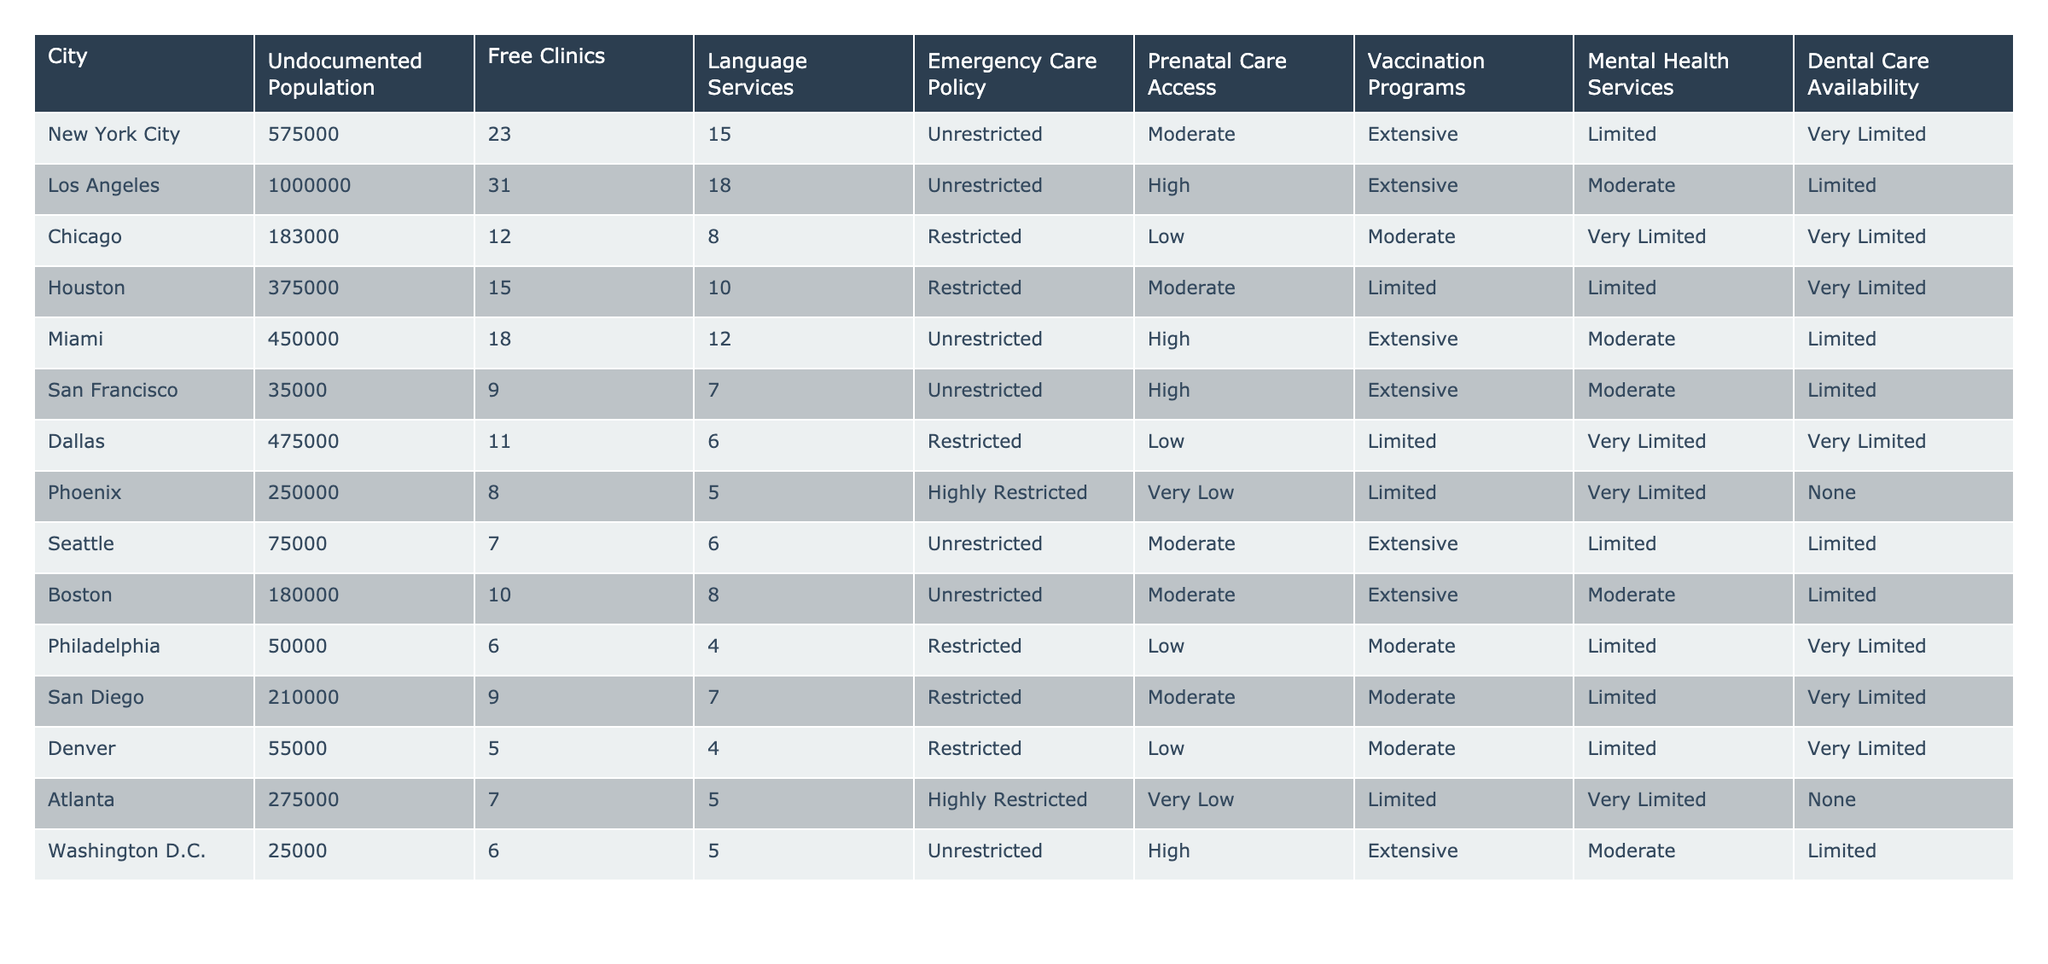What city has the highest undocumented population? By examining the "Undocumented Population" column in the table, Los Angeles has the highest number with 1,000,000.
Answer: Los Angeles Which city has the least access to dental care services for undocumented immigrants? By looking at the "Dental Care Availability" column, both Dallas and Atlanta are marked as "Very Limited," indicating the least access.
Answer: Dallas and Atlanta How many cities have unrestricted emergency care policies? The "Emergency Care Policy" column shows that New York City, Los Angeles, Miami, Seattle, Boston, and Washington D.C. have "Unrestricted" policies, totaling 6 cities.
Answer: 6 What is the average number of free clinics across the cities listed? To find the average, sum the number of free clinics (23 + 31 + 12 + 15 + 18 + 9 + 11 + 8 + 7 + 10 + 6 + 9 + 5 + 7) =  146; divide by the total number of cities, which is 14, giving an average of 146 / 14 ≈ 10.43.
Answer: Approximately 10.43 Which city has the highest number of vaccination programs available? The "Vaccination Programs" column reveals that both New York City, Miami, and San Francisco have "Extensive," but Miami is the only one directly listed with "High," indicating it has the maximum.
Answer: Miami Is prenatal care access restricted in Chicago? The "Prenatal Care Access" column shows "Restricted" for Chicago, confirming that access is indeed restricted.
Answer: Yes Which city has a high availability of mental health services but limited dental care availability? According to the "Mental Health Services" and "Dental Care Availability" columns, Miami has "Extensive" mental health services but "Limited" dental care availability.
Answer: Miami How does the total number of free clinics compare between New York City and Houston? New York City has 23 free clinics while Houston has 15, representing a difference of 8 more clinics in New York City than in Houston.
Answer: New York City has 8 more free clinics Which city has the most access to prenatal care and how is it categorized? Miami has the highest access to prenatal care categorized as "High."
Answer: Miami, High What percentage of cities listed have restricted emergency care policies? There are 5 cities with "Restricted" emergency care policies (Chicago, Houston, Dallas, San Diego, and Atlanta) out of 14 total cities. The percentage is (5/14) * 100 ≈ 35.71%.
Answer: Approximately 35.71% 